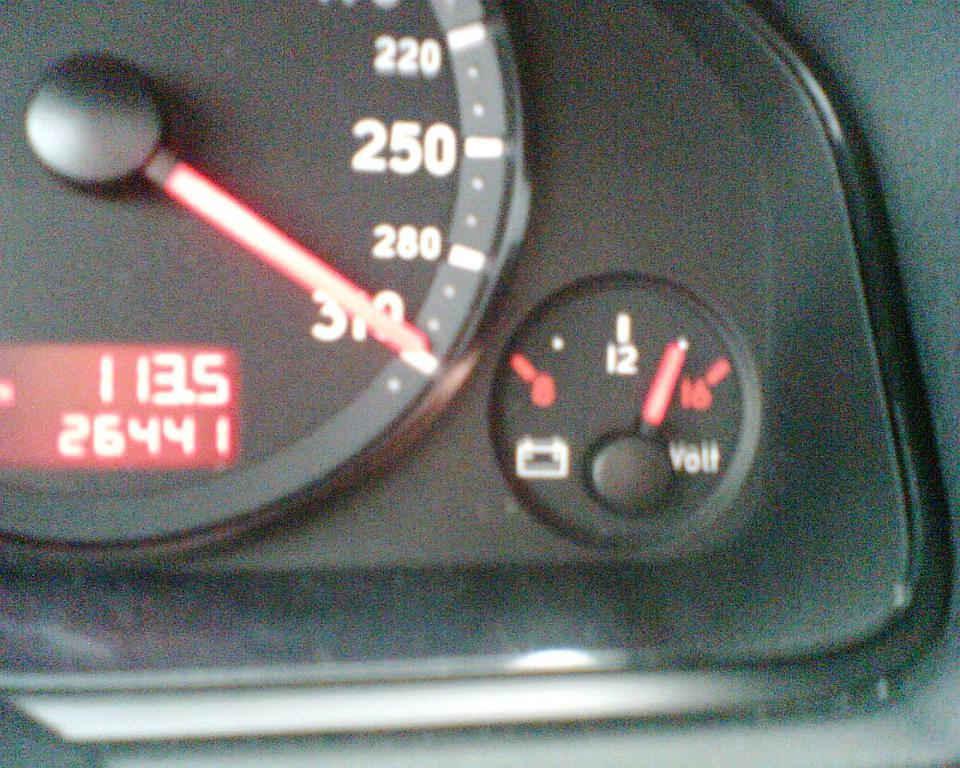What objects are present in the image? There are gauges and pointers in the image. What can be observed about the gauges? The gauges have pointers in the image. What is the color of the background in the image? The background of the image is black. What type of drink is being served through the window in the image? There is no window or drink present in the image; it only features gauges and pointers with a black background. 